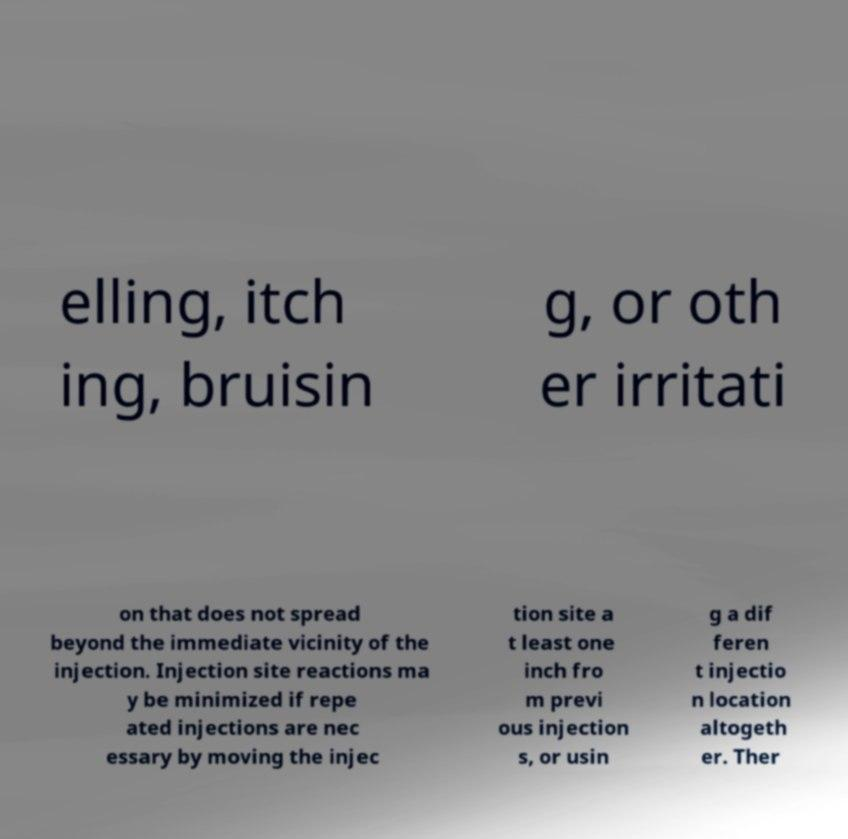Can you accurately transcribe the text from the provided image for me? elling, itch ing, bruisin g, or oth er irritati on that does not spread beyond the immediate vicinity of the injection. Injection site reactions ma y be minimized if repe ated injections are nec essary by moving the injec tion site a t least one inch fro m previ ous injection s, or usin g a dif feren t injectio n location altogeth er. Ther 